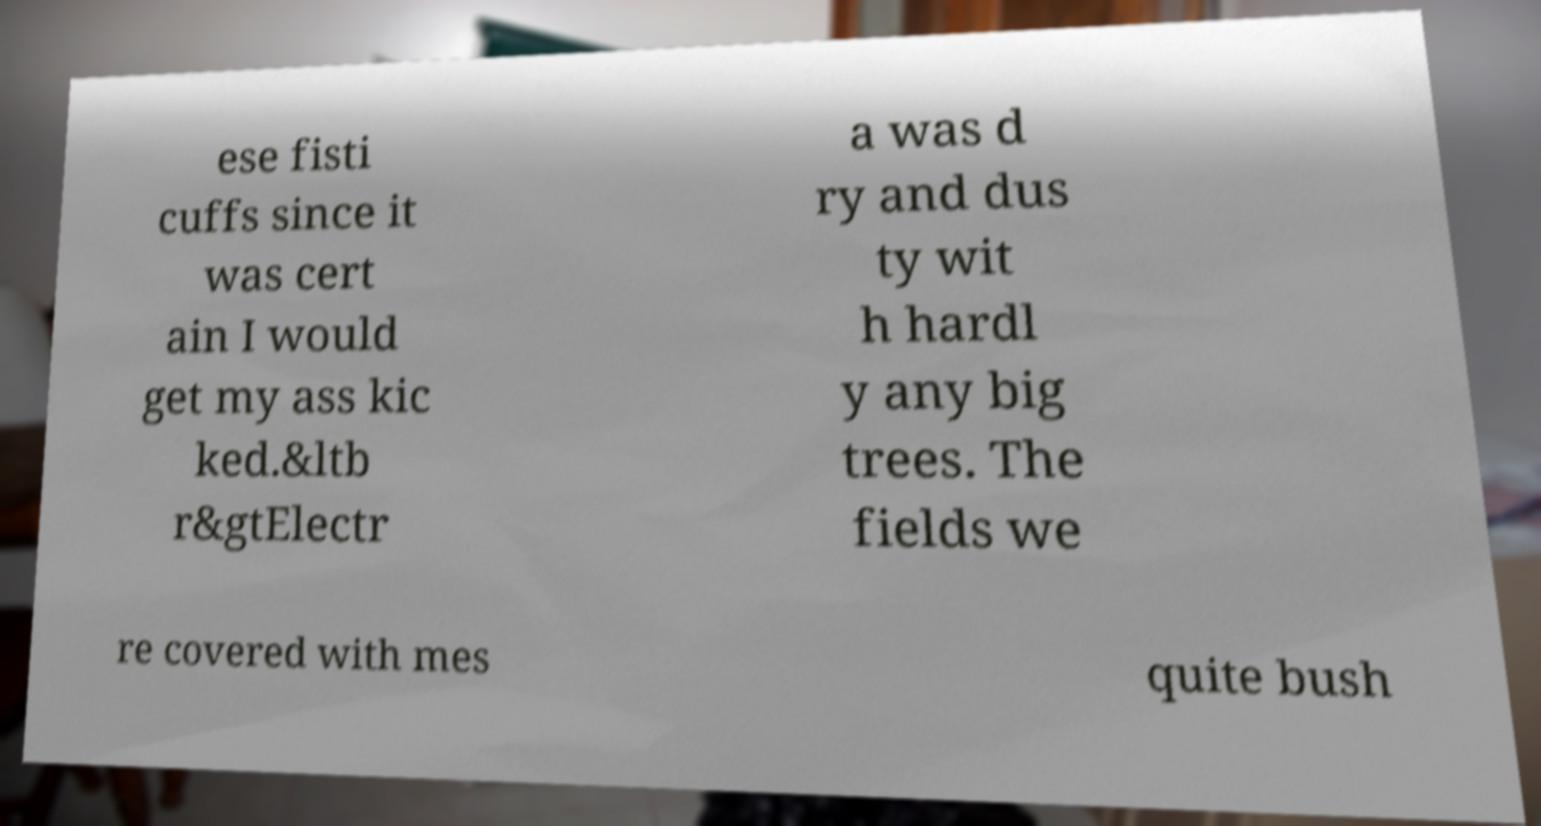Please read and relay the text visible in this image. What does it say? ese fisti cuffs since it was cert ain I would get my ass kic ked.&ltb r&gtElectr a was d ry and dus ty wit h hardl y any big trees. The fields we re covered with mes quite bush 